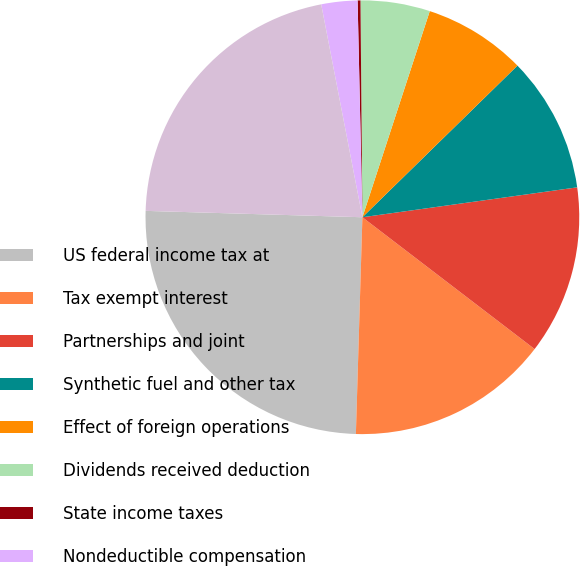Convert chart to OTSL. <chart><loc_0><loc_0><loc_500><loc_500><pie_chart><fcel>US federal income tax at<fcel>Tax exempt interest<fcel>Partnerships and joint<fcel>Synthetic fuel and other tax<fcel>Effect of foreign operations<fcel>Dividends received deduction<fcel>State income taxes<fcel>Nondeductible compensation<fcel>Actual income tax expense<nl><fcel>24.99%<fcel>15.08%<fcel>12.6%<fcel>10.12%<fcel>7.65%<fcel>5.17%<fcel>0.21%<fcel>2.69%<fcel>21.49%<nl></chart> 